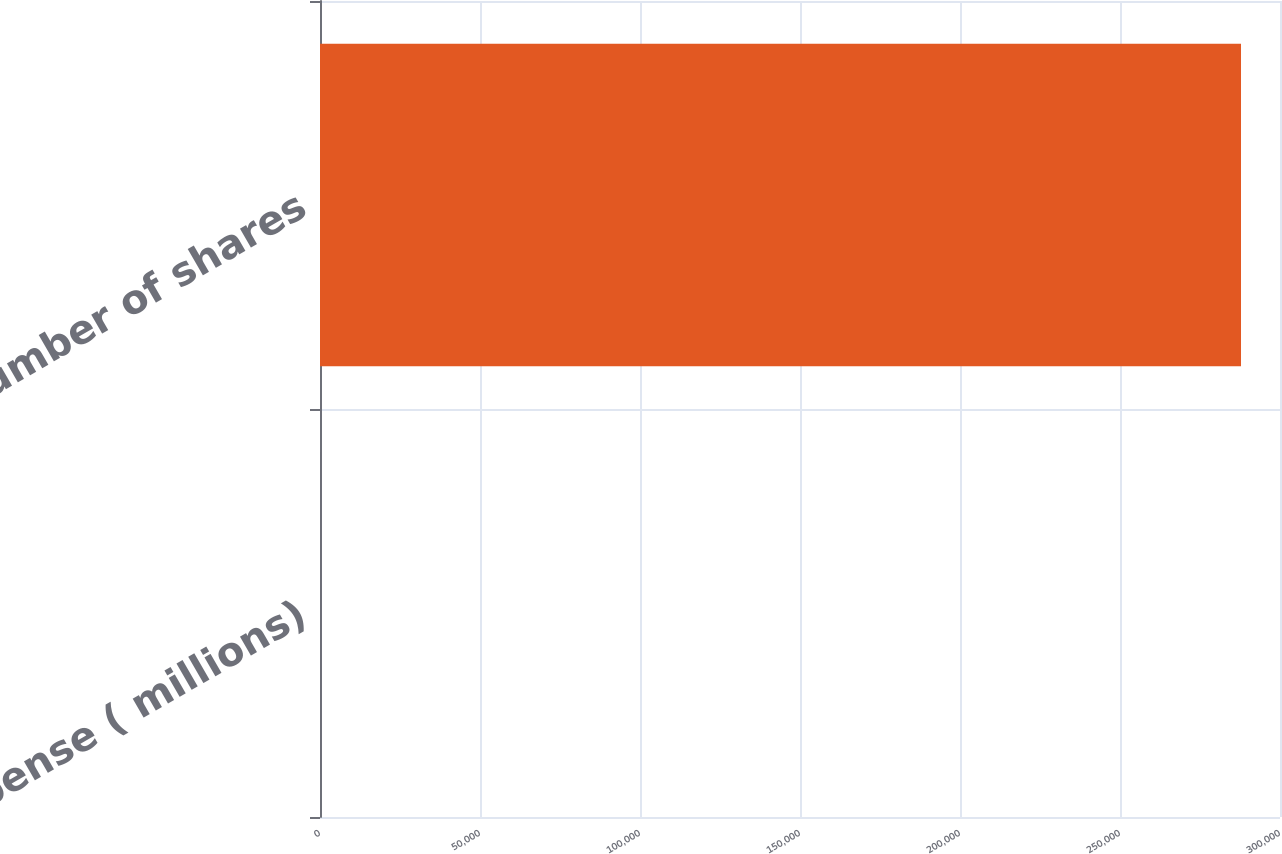<chart> <loc_0><loc_0><loc_500><loc_500><bar_chart><fcel>Expense ( millions)<fcel>Number of shares<nl><fcel>4.3<fcel>287816<nl></chart> 